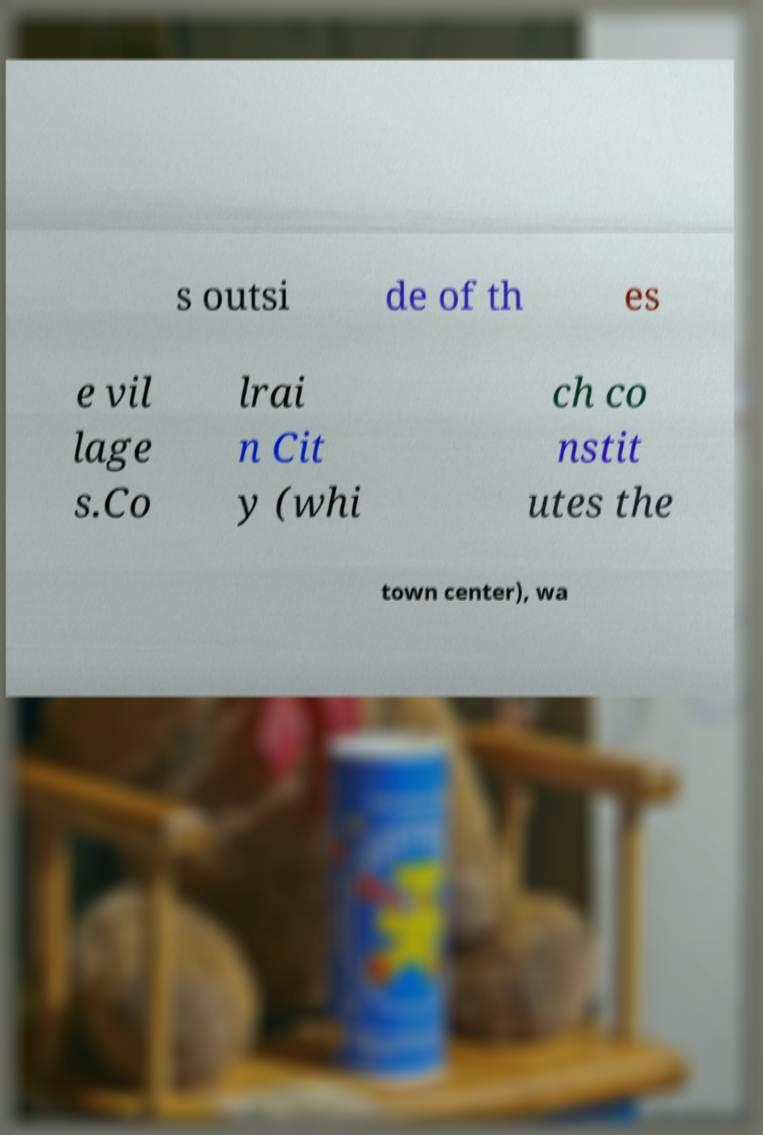Please identify and transcribe the text found in this image. s outsi de of th es e vil lage s.Co lrai n Cit y (whi ch co nstit utes the town center), wa 